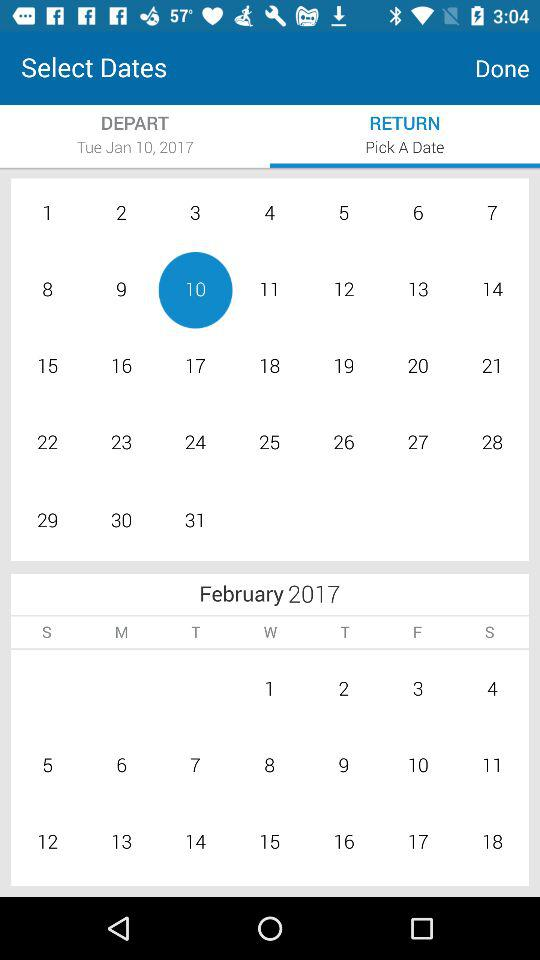Which date has been chosen for return?
When the provided information is insufficient, respond with <no answer>. <no answer> 